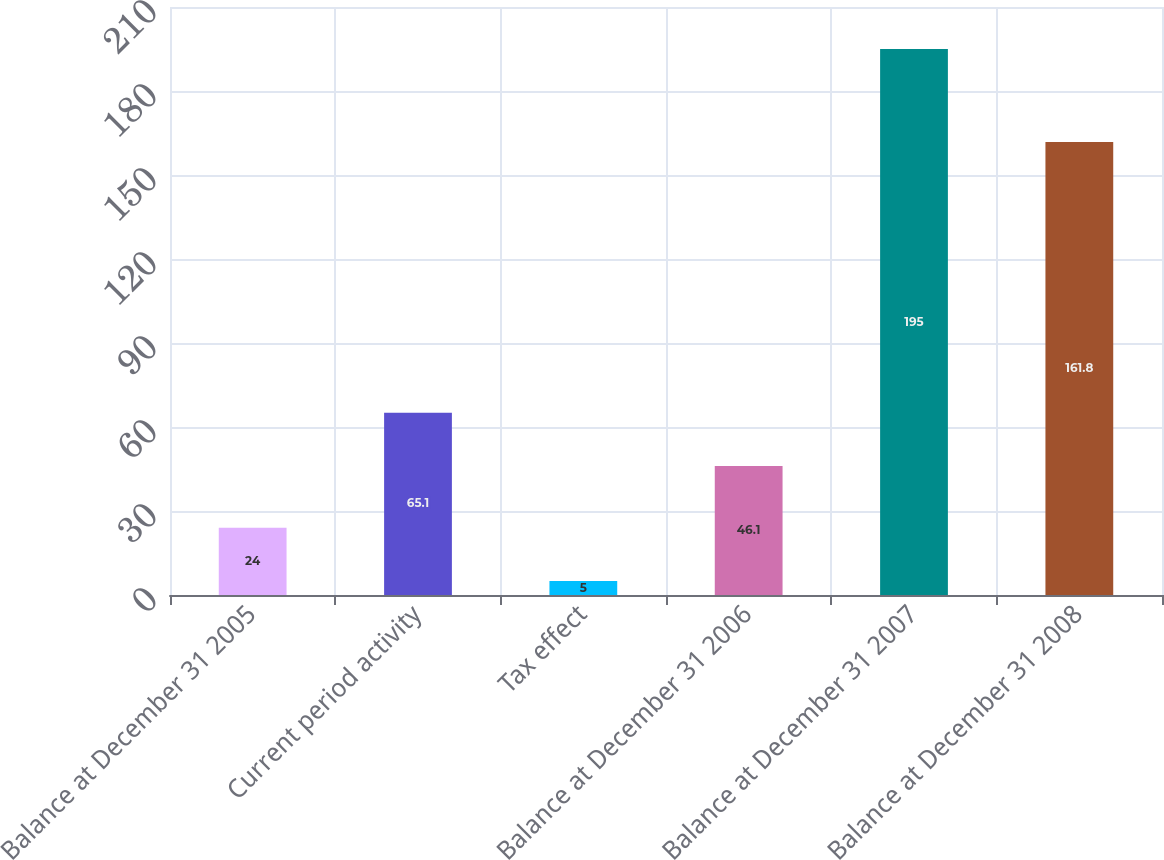Convert chart. <chart><loc_0><loc_0><loc_500><loc_500><bar_chart><fcel>Balance at December 31 2005<fcel>Current period activity<fcel>Tax effect<fcel>Balance at December 31 2006<fcel>Balance at December 31 2007<fcel>Balance at December 31 2008<nl><fcel>24<fcel>65.1<fcel>5<fcel>46.1<fcel>195<fcel>161.8<nl></chart> 